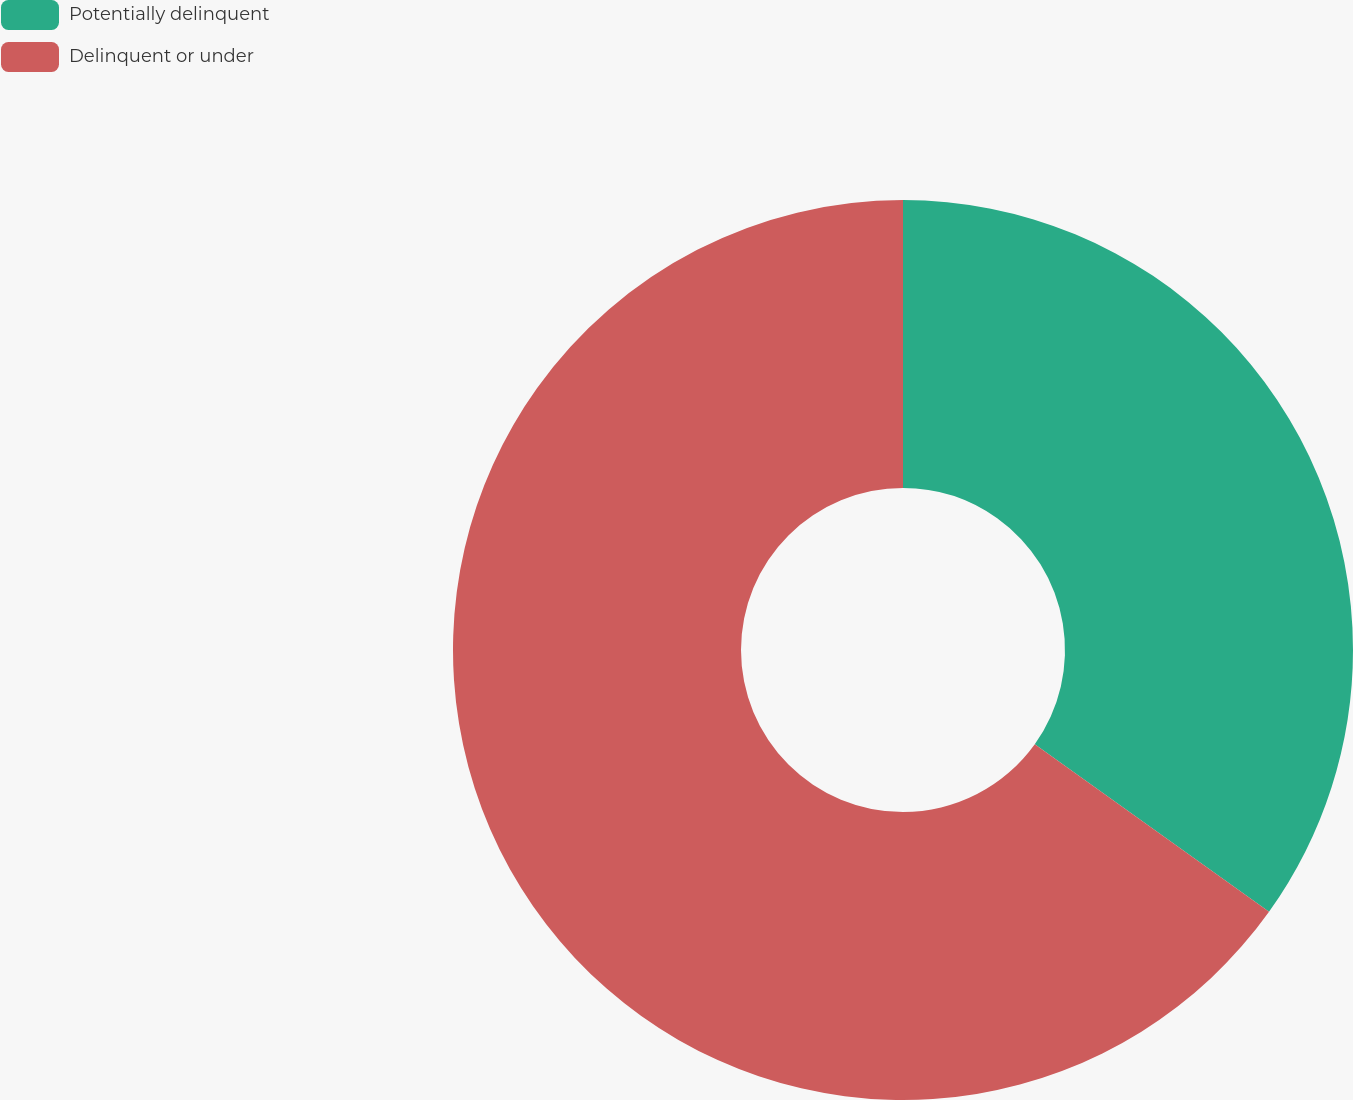<chart> <loc_0><loc_0><loc_500><loc_500><pie_chart><fcel>Potentially delinquent<fcel>Delinquent or under<nl><fcel>34.88%<fcel>65.12%<nl></chart> 